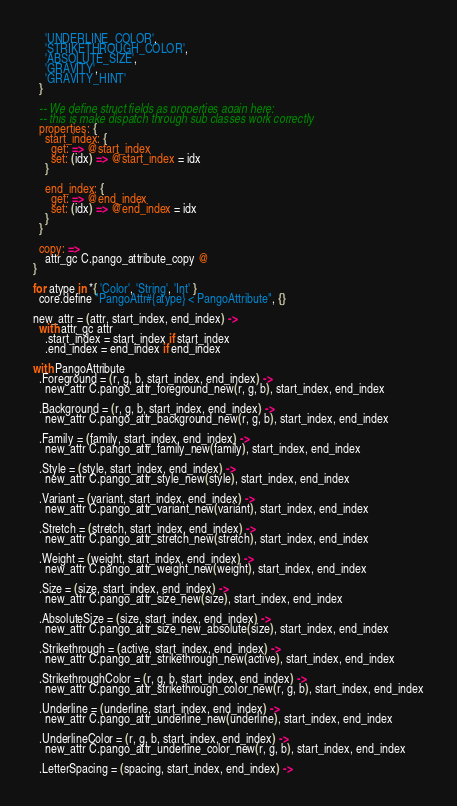Convert code to text. <code><loc_0><loc_0><loc_500><loc_500><_MoonScript_>    'UNDERLINE_COLOR',
    'STRIKETHROUGH_COLOR',
    'ABSOLUTE_SIZE',
    'GRAVITY',
    'GRAVITY_HINT'
  }

  -- We define struct fields as properties again here:
  -- this is make dispatch through sub classes work correctly
  properties: {
    start_index: {
      get: => @start_index
      set: (idx) => @start_index = idx
    }

    end_index: {
      get: => @end_index
      set: (idx) => @end_index = idx
    }
  }

  copy: =>
    attr_gc C.pango_attribute_copy @
}

for atype in *{ 'Color', 'String', 'Int' }
  core.define "PangoAttr#{atype} < PangoAttribute", {}

new_attr = (attr, start_index, end_index) ->
  with attr_gc attr
    .start_index = start_index if start_index
    .end_index = end_index if end_index

with PangoAttribute
  .Foreground = (r, g, b, start_index, end_index) ->
    new_attr C.pango_attr_foreground_new(r, g, b), start_index, end_index

  .Background = (r, g, b, start_index, end_index) ->
    new_attr C.pango_attr_background_new(r, g, b), start_index, end_index

  .Family = (family, start_index, end_index) ->
    new_attr C.pango_attr_family_new(family), start_index, end_index

  .Style = (style, start_index, end_index) ->
    new_attr C.pango_attr_style_new(style), start_index, end_index

  .Variant = (variant, start_index, end_index) ->
    new_attr C.pango_attr_variant_new(variant), start_index, end_index

  .Stretch = (stretch, start_index, end_index) ->
    new_attr C.pango_attr_stretch_new(stretch), start_index, end_index

  .Weight = (weight, start_index, end_index) ->
    new_attr C.pango_attr_weight_new(weight), start_index, end_index

  .Size = (size, start_index, end_index) ->
    new_attr C.pango_attr_size_new(size), start_index, end_index

  .AbsoluteSize = (size, start_index, end_index) ->
    new_attr C.pango_attr_size_new_absolute(size), start_index, end_index

  .Strikethrough = (active, start_index, end_index) ->
    new_attr C.pango_attr_strikethrough_new(active), start_index, end_index

  .StrikethroughColor = (r, g, b, start_index, end_index) ->
    new_attr C.pango_attr_strikethrough_color_new(r, g, b), start_index, end_index

  .Underline = (underline, start_index, end_index) ->
    new_attr C.pango_attr_underline_new(underline), start_index, end_index

  .UnderlineColor = (r, g, b, start_index, end_index) ->
    new_attr C.pango_attr_underline_color_new(r, g, b), start_index, end_index

  .LetterSpacing = (spacing, start_index, end_index) -></code> 